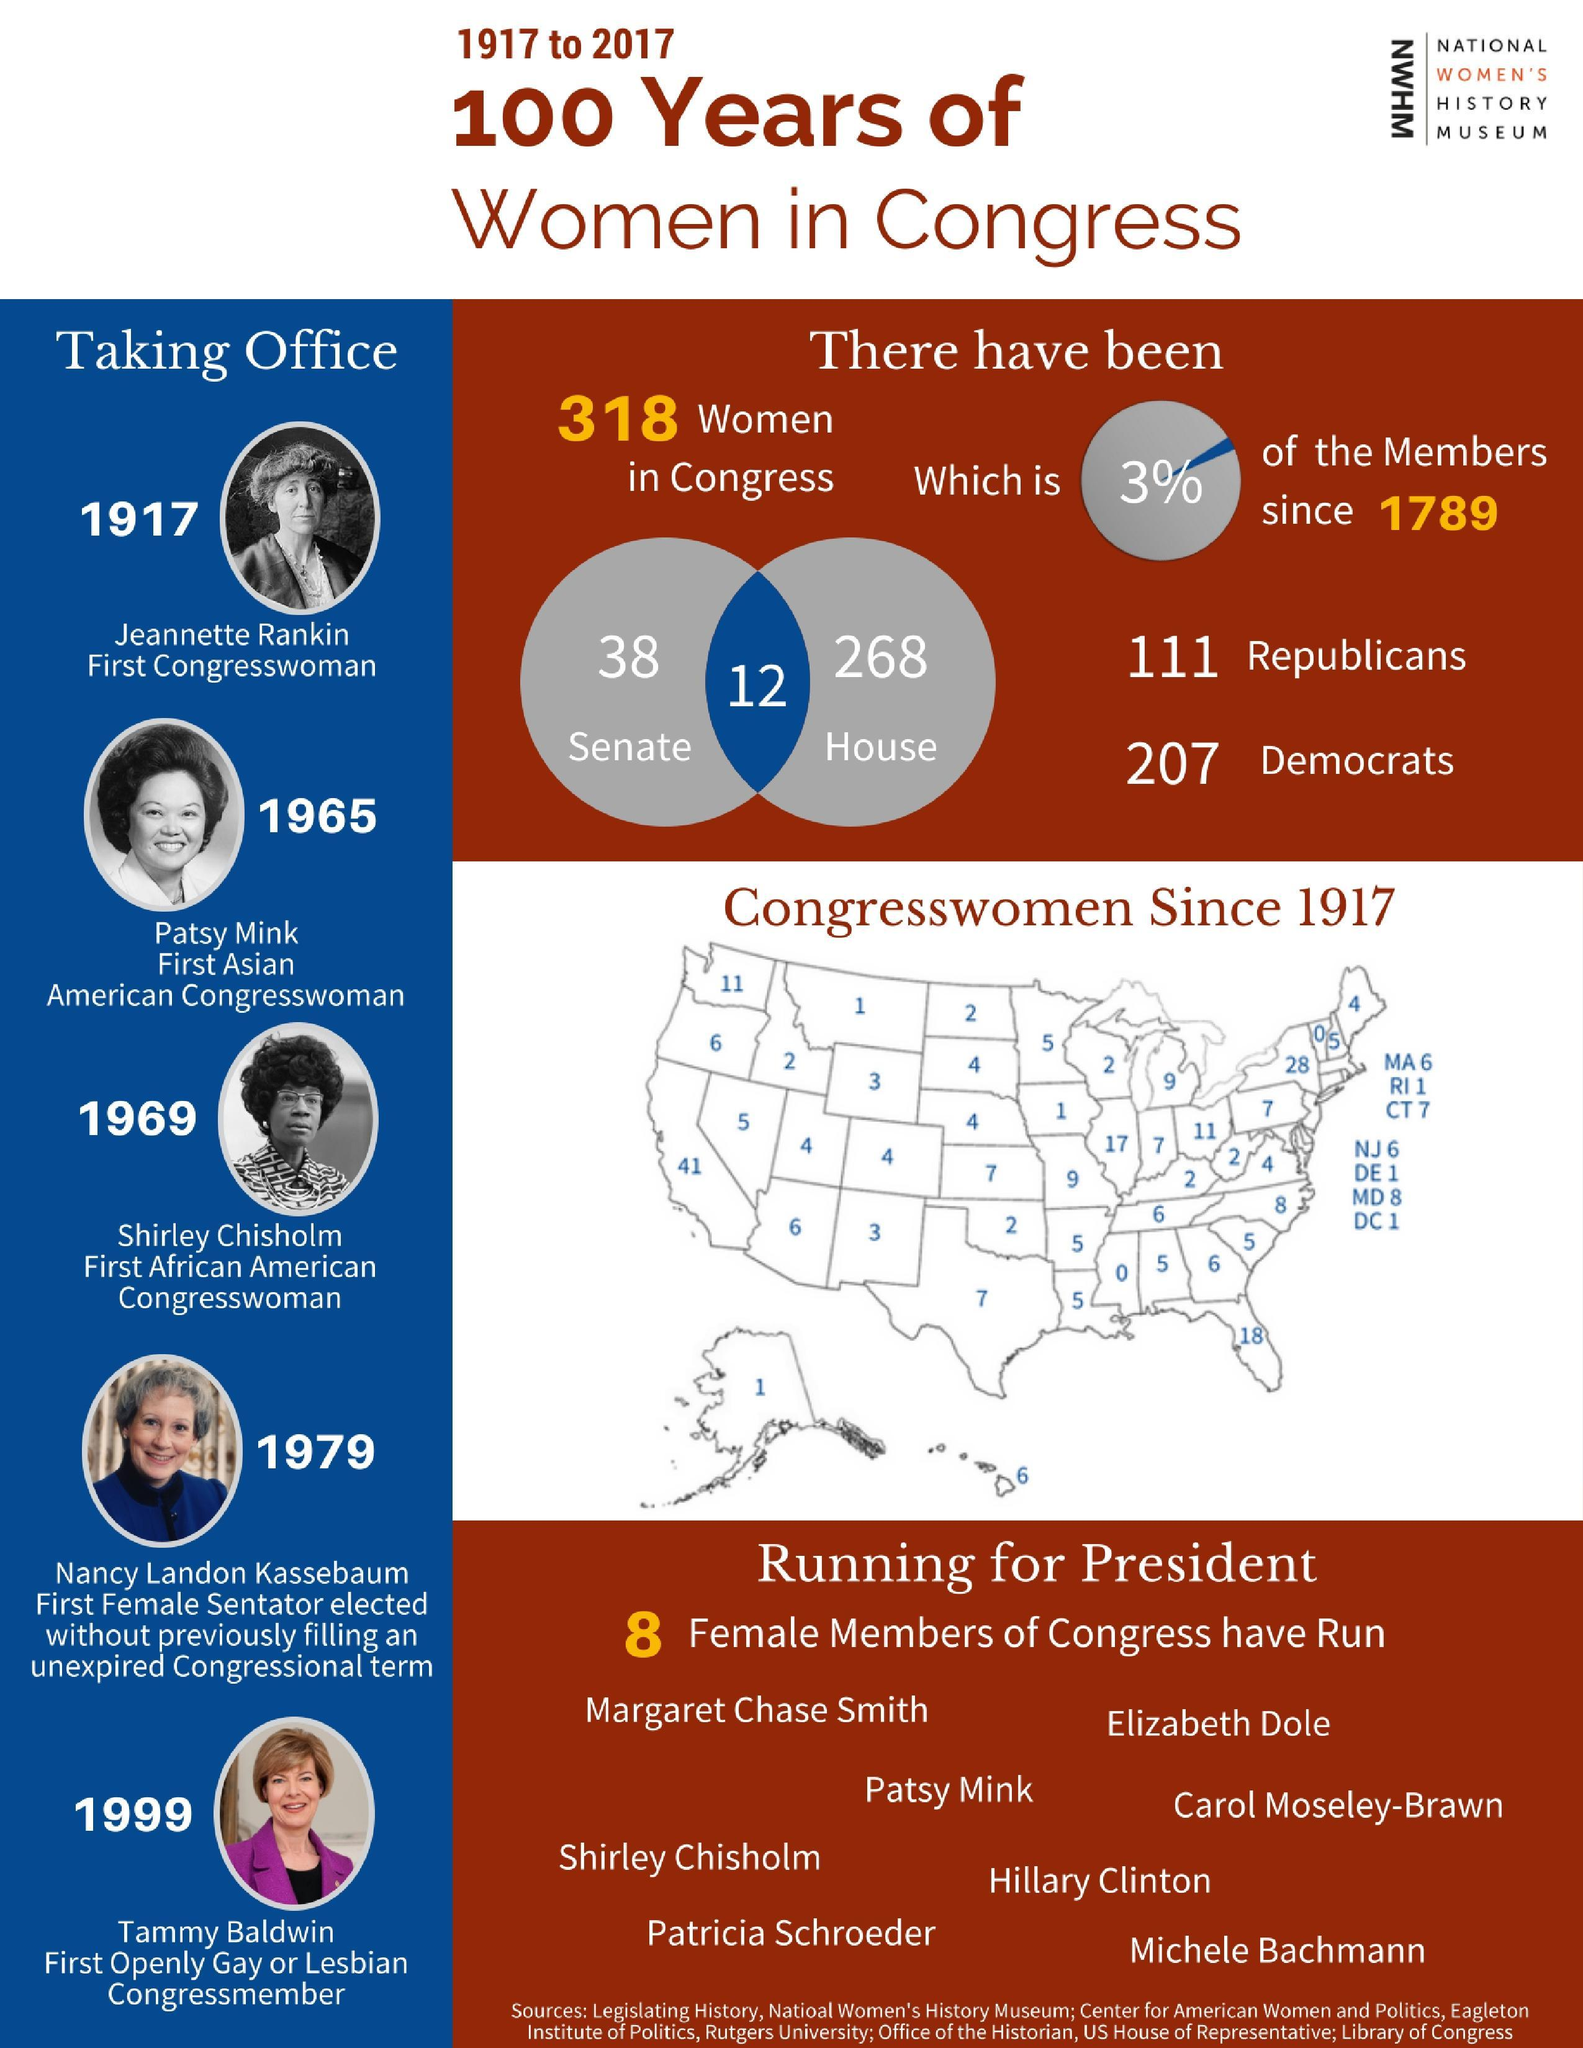Highlight a few significant elements in this photo. The first African American Congresswoman took charge in 1969. During the period of 1917 to 2017, a total of 207 women in the United States Congress were Democrats. Jeannette Rankin was the first woman elected to the United States Congress. Since 1789, only 3% of the members in the U.S. congress have been women. During the period of 1917 to 2017, there was only one congresswoman from the state of Alaska. 